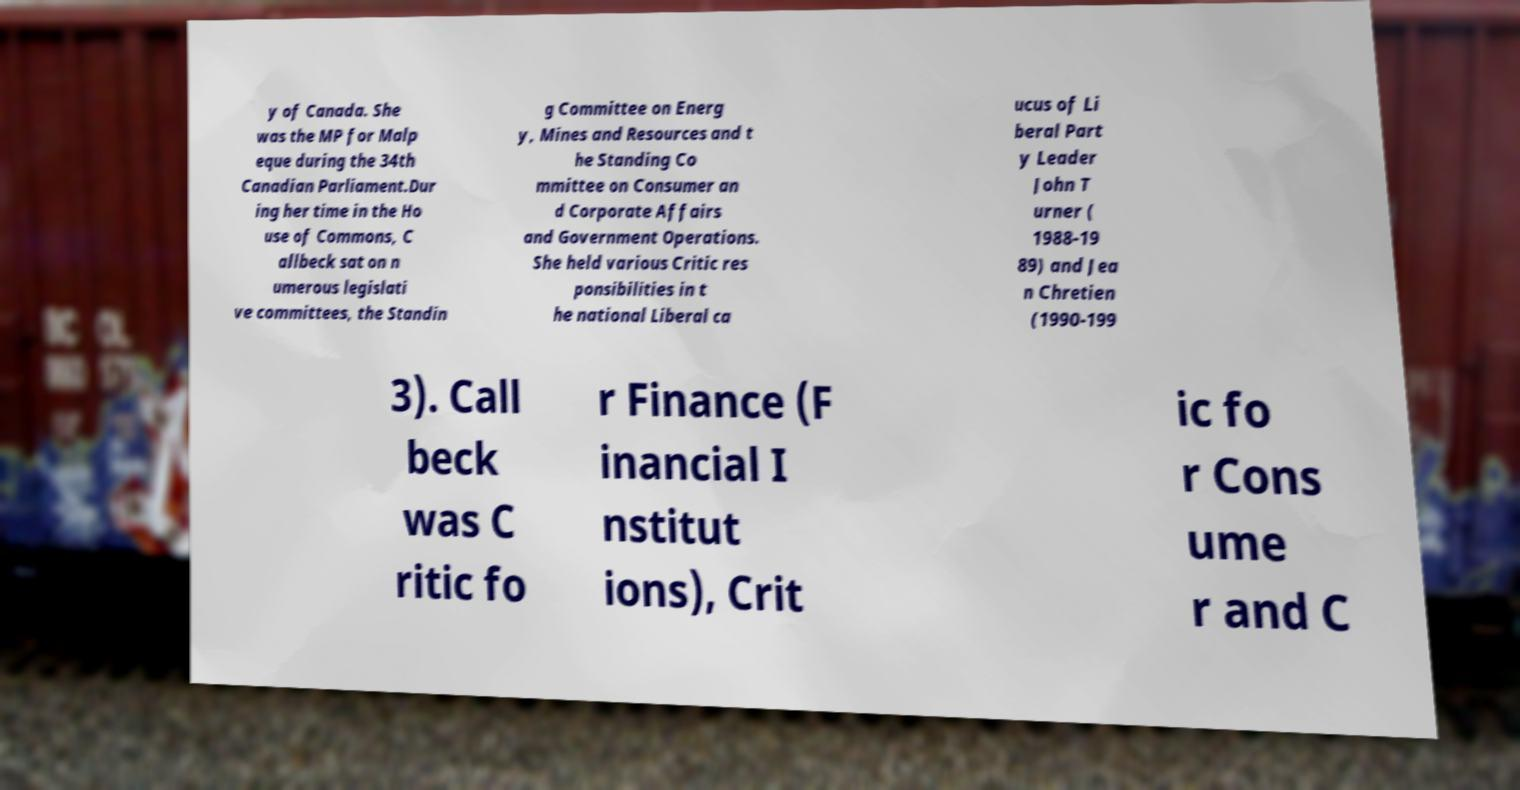I need the written content from this picture converted into text. Can you do that? y of Canada. She was the MP for Malp eque during the 34th Canadian Parliament.Dur ing her time in the Ho use of Commons, C allbeck sat on n umerous legislati ve committees, the Standin g Committee on Energ y, Mines and Resources and t he Standing Co mmittee on Consumer an d Corporate Affairs and Government Operations. She held various Critic res ponsibilities in t he national Liberal ca ucus of Li beral Part y Leader John T urner ( 1988-19 89) and Jea n Chretien (1990-199 3). Call beck was C ritic fo r Finance (F inancial I nstitut ions), Crit ic fo r Cons ume r and C 